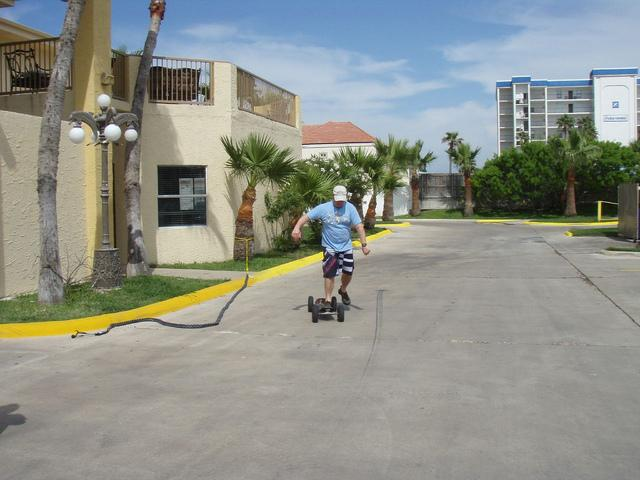What is unusual about the man's skateboard? wheels 